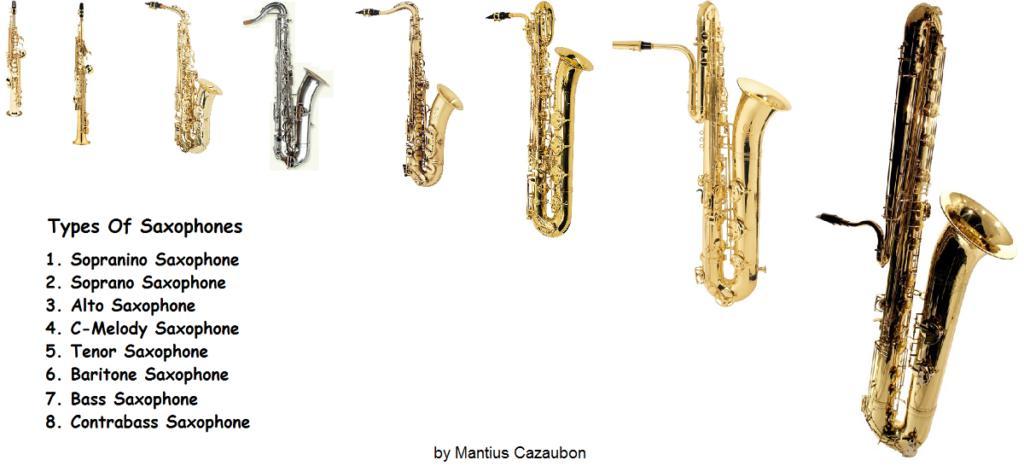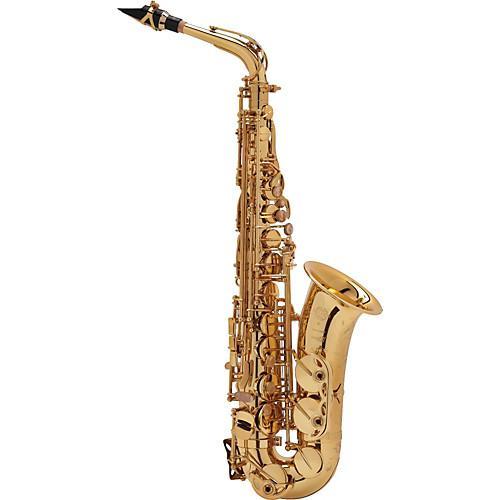The first image is the image on the left, the second image is the image on the right. For the images shown, is this caption "There are the same number of saxophones in each of the images." true? Answer yes or no. No. The first image is the image on the left, the second image is the image on the right. Considering the images on both sides, is "Each image shows just one saxophone that is out of its case." valid? Answer yes or no. No. 